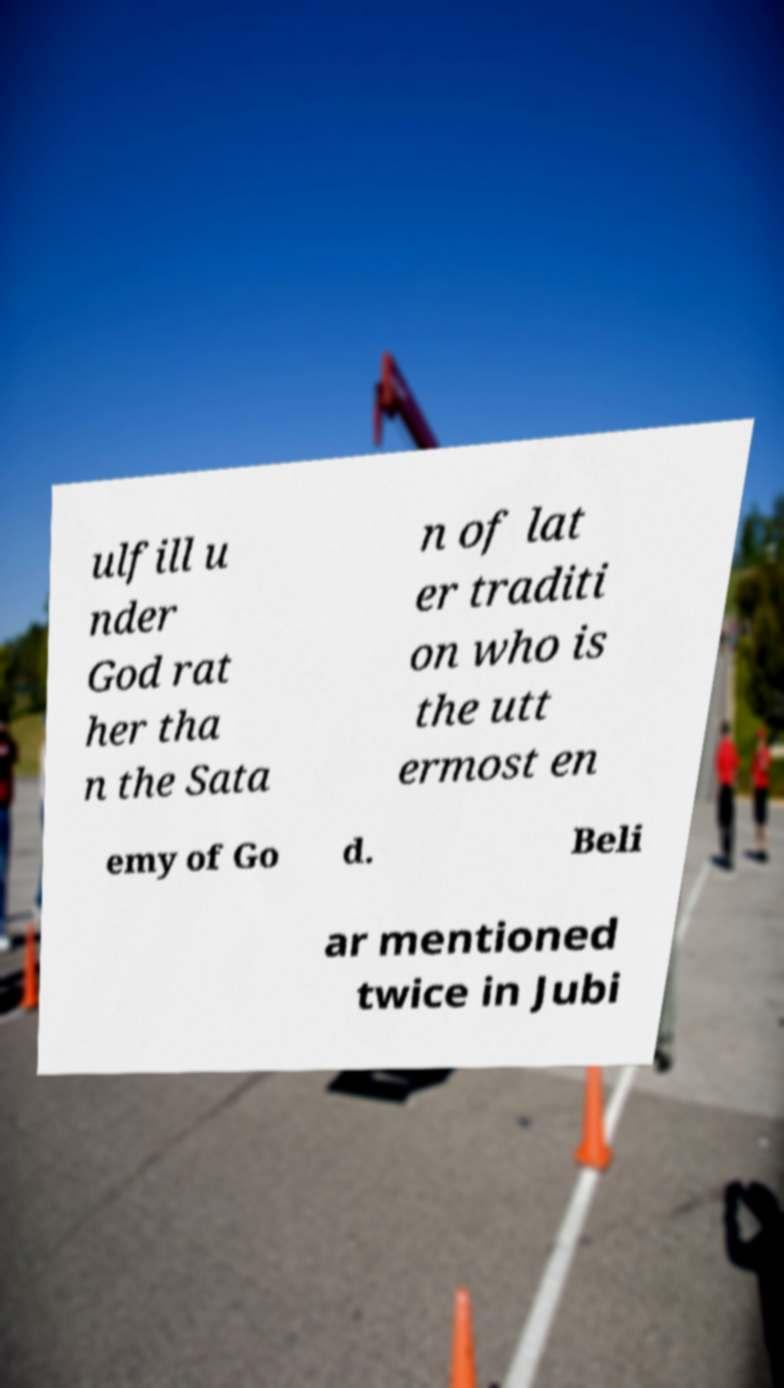Could you assist in decoding the text presented in this image and type it out clearly? ulfill u nder God rat her tha n the Sata n of lat er traditi on who is the utt ermost en emy of Go d. Beli ar mentioned twice in Jubi 